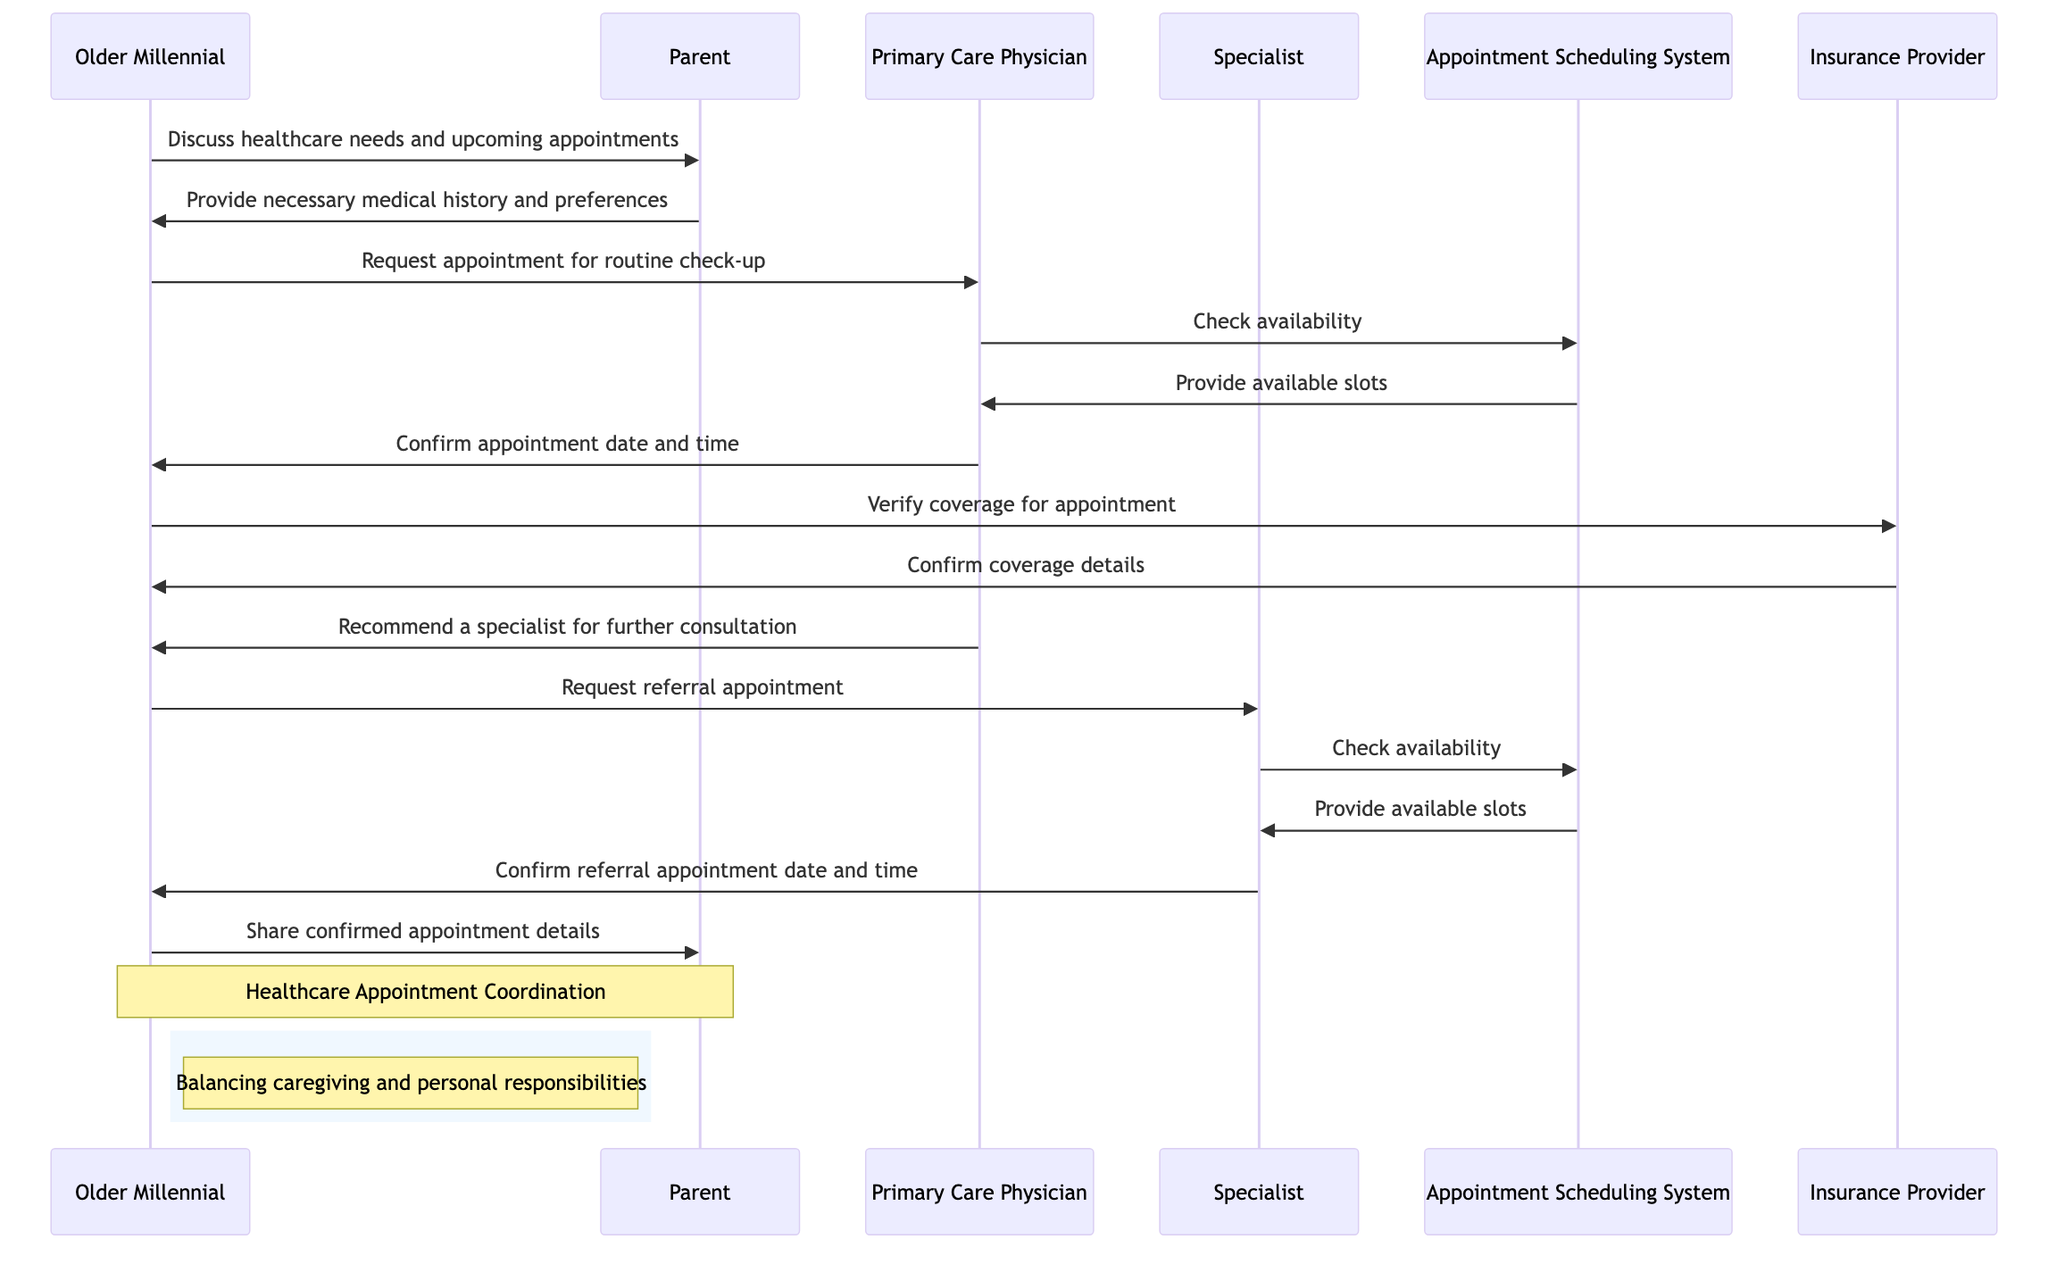What is the first action taken by the Older Millennial? The first action taken by the Older Millennial in the sequence diagram is to discuss healthcare needs and upcoming appointments with the Parent. This is indicated by the first message in the sequence where the Older Millennial sends a message to the Parent.
Answer: Discuss healthcare needs and upcoming appointments How many participants are involved in the sequence diagram? The sequence diagram lists six participants: Older Millennial, Parent, Primary Care Physician, Specialist, Appointment Scheduling System, and Insurance Provider. By counting each unique participant, we find a total of six.
Answer: Six Who does the Primary Care Physician communicate with to check availability? The Primary Care Physician communicates with the Appointment Scheduling System to check availability. This is shown in the diagram where the Primary Care Physician sends a message to the Appointment Scheduling System to request available slots.
Answer: Appointment Scheduling System What does the Older Millennial verify with the Insurance Provider? The Older Millennial verifies the coverage for the appointment with the Insurance Provider. This is a direct message in the sequence that illustrates their inquiry to ensure the appointment is covered by insurance.
Answer: Verify coverage for appointment What action follows the Primary Care Physician recommending a specialist? The action that follows after the Primary Care Physician recommends a specialist is that the Older Millennial requests a referral appointment with the Specialist. This message sequence shows the transition from one healthcare provider to another based on the recommendation given.
Answer: Request referral appointment Which participant confirms the appointment date and time for the referral? The Specialist confirms the referral appointment date and time. This occurs as the Specialist sends a confirmation message back to the Older Millennial after checking availability via the Appointment Scheduling System.
Answer: Specialist What role does the Appointment Scheduling System play in this diagram? The Appointment Scheduling System acts as an intermediary that facilitates communication between the Primary Care Physician and Specialist to check availability and provide available appointment slots. Its role is crucial in coordinating the scheduling aspect of the healthcare appointments.
Answer: Coordination How many steps are involved from the first action to sharing appointment details? There are twelve steps involved from the first action of discussing healthcare needs to sharing the confirmed appointment details with the Parent. Counting each communication flow shows the progression of actions that occur in the sequence.
Answer: Twelve 